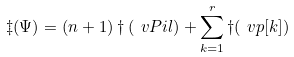Convert formula to latex. <formula><loc_0><loc_0><loc_500><loc_500>\ddagger ( \Psi ) = ( n + 1 ) \dagger ( \ v P i l ) + \sum _ { k = 1 } ^ { r } \dagger ( \ v p [ k ] )</formula> 